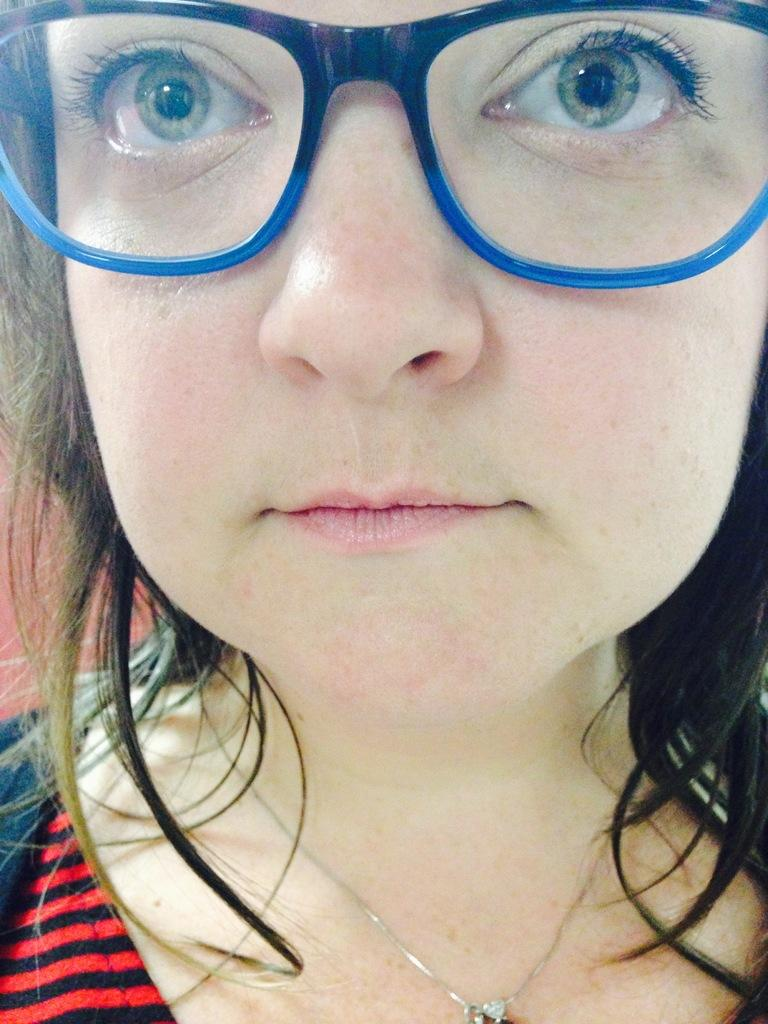Who is the main subject in the image? There is a woman in the image. What is the woman wearing? The woman is wearing a red dress and blue colored spectacles. Can you see a frog hopping around the woman in the image? No, there is no frog present in the image. What type of powder is being used by the woman in the image? There is no powder visible in the image, and the woman is not using any powder. 